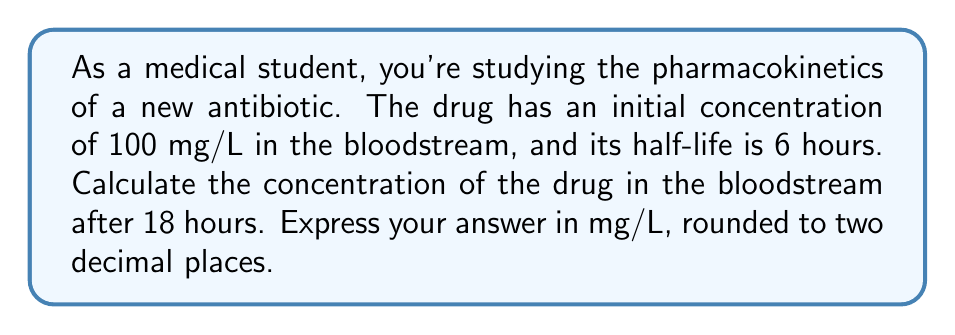Teach me how to tackle this problem. To solve this problem, we'll use the exponential decay formula for half-life:

$$C(t) = C_0 \cdot (\frac{1}{2})^{\frac{t}{t_{1/2}}}$$

Where:
$C(t)$ = Concentration at time $t$
$C_0$ = Initial concentration
$t$ = Time elapsed
$t_{1/2}$ = Half-life of the drug

Given:
$C_0 = 100$ mg/L
$t_{1/2} = 6$ hours
$t = 18$ hours

Let's substitute these values into the formula:

$$C(18) = 100 \cdot (\frac{1}{2})^{\frac{18}{6}}$$

Simplify the exponent:
$$C(18) = 100 \cdot (\frac{1}{2})^3$$

Calculate the power:
$$C(18) = 100 \cdot \frac{1}{8}$$

Multiply:
$$C(18) = 12.5$$

Therefore, the concentration of the drug after 18 hours is 12.5 mg/L.
Answer: 12.50 mg/L 